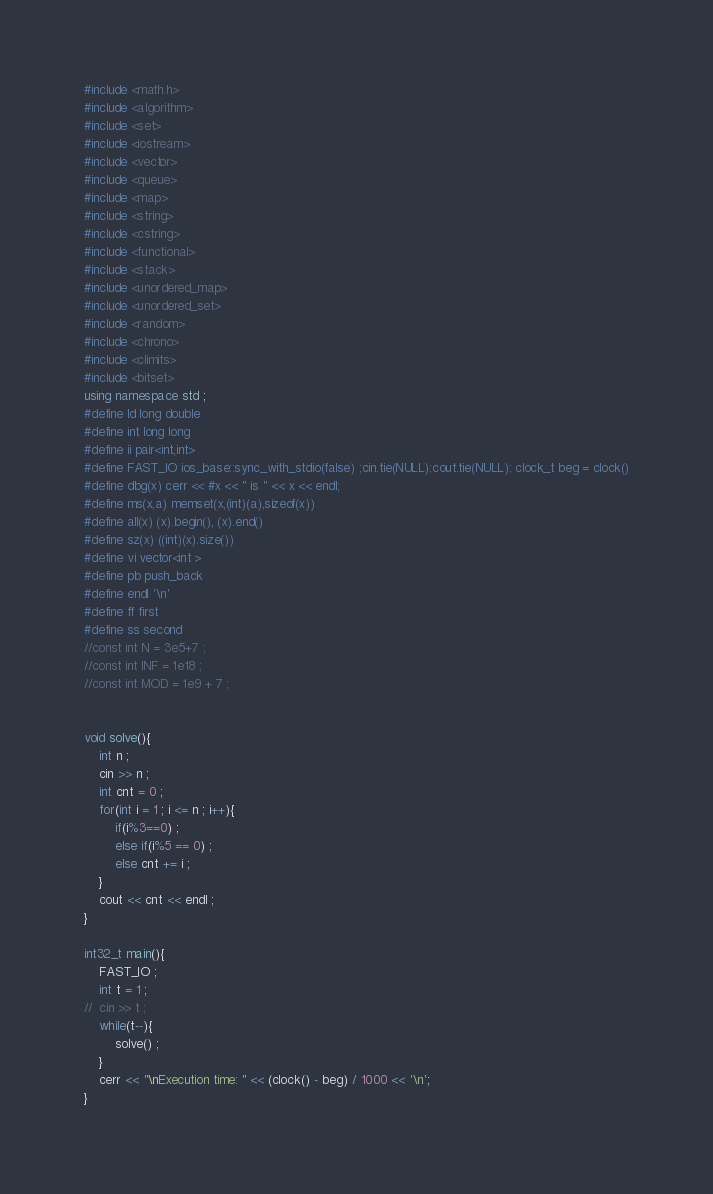<code> <loc_0><loc_0><loc_500><loc_500><_C++_>#include <math.h>
#include <algorithm>
#include <set>
#include <iostream>
#include <vector>
#include <queue>
#include <map>
#include <string>
#include <cstring>
#include <functional>
#include <stack>
#include <unordered_map>
#include <unordered_set>
#include <random>
#include <chrono>
#include <climits>
#include <bitset>
using namespace std ;
#define ld long double
#define int long long
#define ii pair<int,int>
#define FAST_IO ios_base::sync_with_stdio(false) ;cin.tie(NULL);cout.tie(NULL); clock_t beg = clock()
#define dbg(x) cerr << #x << " is " << x << endl;
#define ms(x,a) memset(x,(int)(a),sizeof(x))
#define all(x) (x).begin(), (x).end()
#define sz(x) ((int)(x).size())
#define vi vector<int >
#define pb push_back
#define endl '\n'
#define ff first
#define ss second
//const int N = 3e5+7 ;
//const int INF = 1e18 ;
//const int MOD = 1e9 + 7 ;


void solve(){
	int n ;
	cin >> n ;
	int cnt = 0 ;
	for(int i = 1 ; i <= n ; i++){
		if(i%3==0) ;
		else if(i%5 == 0) ;
		else cnt += i ;
	}
	cout << cnt << endl ;
}

int32_t main(){
	FAST_IO ;
	int t = 1 ;
//	cin >> t ;
	while(t--){
		solve() ;
	}
    cerr << "\nExecution time: " << (clock() - beg) / 1000 << '\n';
}
</code> 